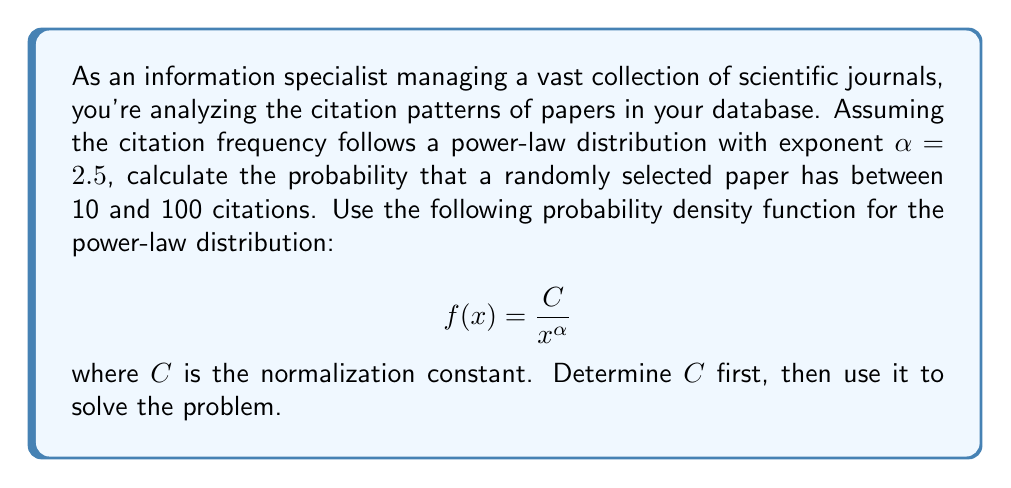Can you answer this question? 1. First, we need to determine the normalization constant $C$. For a power-law distribution with a minimum value of 1, we have:

   $$\int_1^{\infty} \frac{C}{x^{\alpha}} dx = 1$$

2. Solving for $C$:
   $$C \int_1^{\infty} x^{-2.5} dx = 1$$
   $$C \left[ -\frac{x^{-1.5}}{1.5} \right]_1^{\infty} = 1$$
   $$C \left( 0 - \left(-\frac{1}{1.5}\right) \right) = 1$$
   $$C = 1.5$$

3. Now that we have $C$, we can calculate the probability of a paper having between 10 and 100 citations:

   $$P(10 \leq X \leq 100) = \int_{10}^{100} \frac{1.5}{x^{2.5}} dx$$

4. Evaluating the integral:
   $$P(10 \leq X \leq 100) = 1.5 \int_{10}^{100} x^{-2.5} dx$$
   $$= 1.5 \left[ -\frac{x^{-1.5}}{1.5} \right]_{10}^{100}$$
   $$= \left[ -x^{-1.5} \right]_{10}^{100}$$
   $$= -100^{-1.5} - (-10^{-1.5})$$
   $$= -\frac{1}{1000} + \frac{1}{31.6227766}$$
   $$\approx 0.0306227766$$

5. Converting to a percentage:
   $$0.0306227766 \times 100\% \approx 3.06\%$$
Answer: 3.06% 